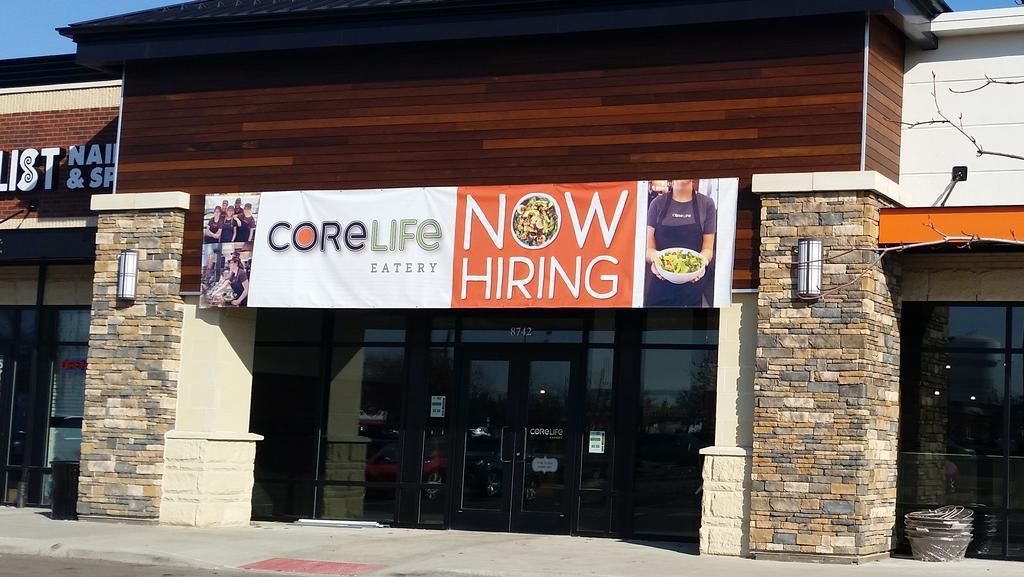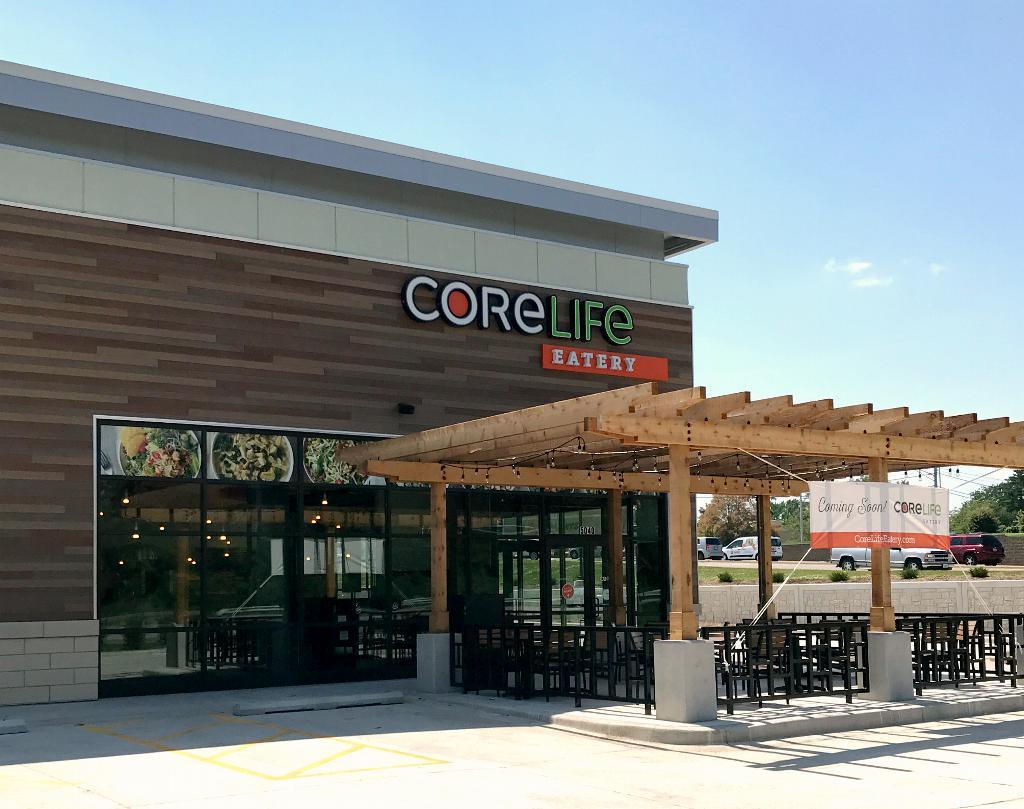The first image is the image on the left, the second image is the image on the right. Given the left and right images, does the statement "A white and orange banner is hanging on the front of a restaurant." hold true? Answer yes or no. Yes. The first image is the image on the left, the second image is the image on the right. Considering the images on both sides, is "Two restaurants are displaying a permanent sign with the name Core Life Eatery." valid? Answer yes or no. No. 